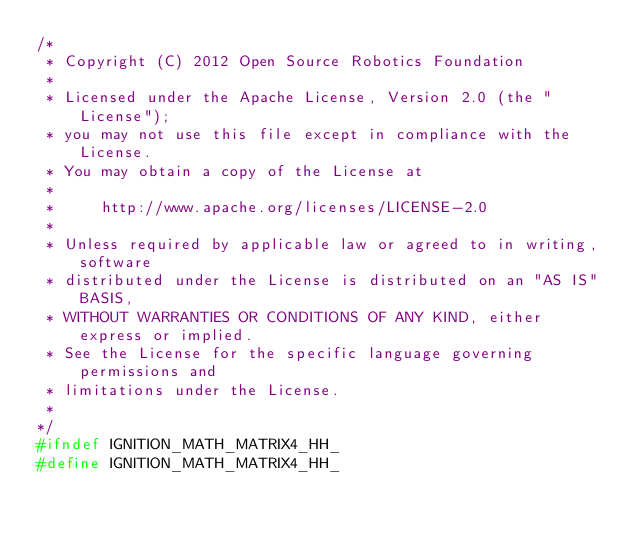Convert code to text. <code><loc_0><loc_0><loc_500><loc_500><_C++_>/*
 * Copyright (C) 2012 Open Source Robotics Foundation
 *
 * Licensed under the Apache License, Version 2.0 (the "License");
 * you may not use this file except in compliance with the License.
 * You may obtain a copy of the License at
 *
 *     http://www.apache.org/licenses/LICENSE-2.0
 *
 * Unless required by applicable law or agreed to in writing, software
 * distributed under the License is distributed on an "AS IS" BASIS,
 * WITHOUT WARRANTIES OR CONDITIONS OF ANY KIND, either express or implied.
 * See the License for the specific language governing permissions and
 * limitations under the License.
 *
*/
#ifndef IGNITION_MATH_MATRIX4_HH_
#define IGNITION_MATH_MATRIX4_HH_
</code> 